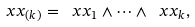Convert formula to latex. <formula><loc_0><loc_0><loc_500><loc_500>\ x x _ { ( k ) } = \ x x _ { 1 } \wedge \cdots \wedge \ x x _ { k } ,</formula> 